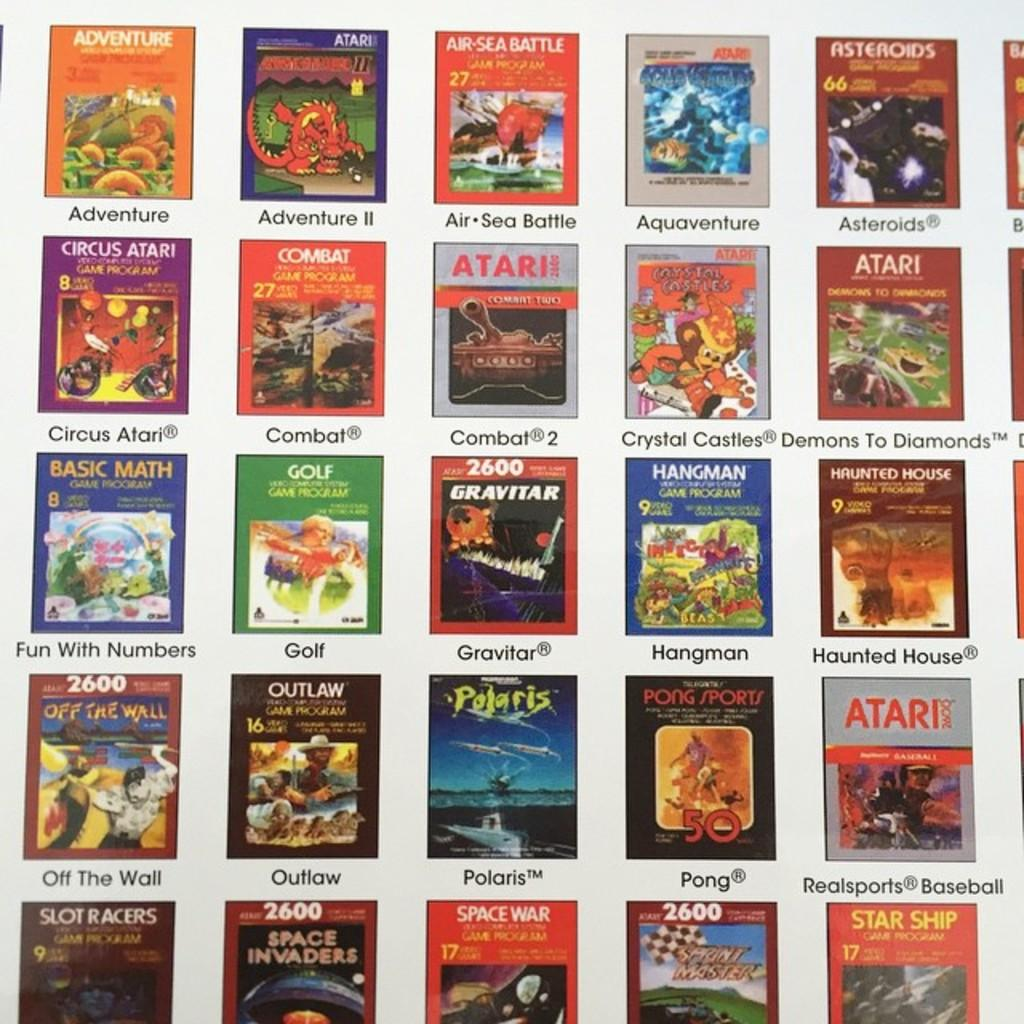<image>
Summarize the visual content of the image. Collection of books of math, golf, atari, and space 